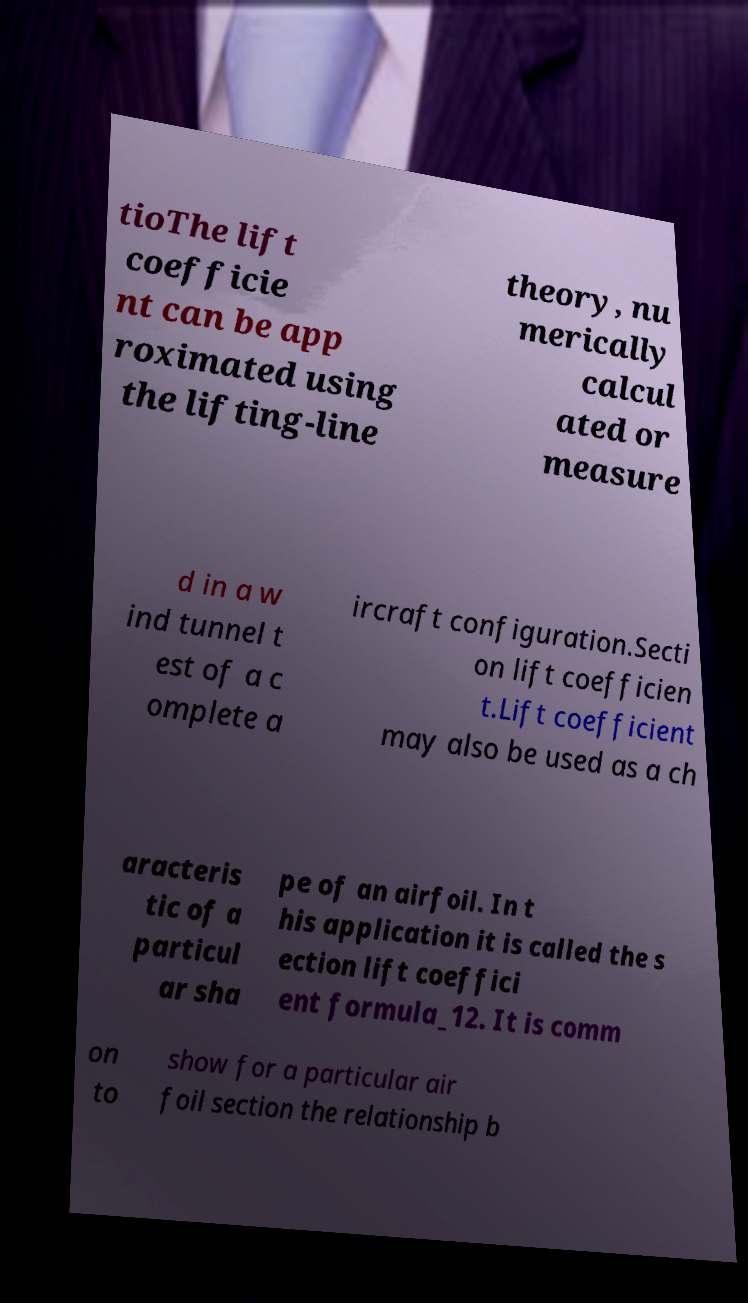Please read and relay the text visible in this image. What does it say? tioThe lift coefficie nt can be app roximated using the lifting-line theory, nu merically calcul ated or measure d in a w ind tunnel t est of a c omplete a ircraft configuration.Secti on lift coefficien t.Lift coefficient may also be used as a ch aracteris tic of a particul ar sha pe of an airfoil. In t his application it is called the s ection lift coeffici ent formula_12. It is comm on to show for a particular air foil section the relationship b 